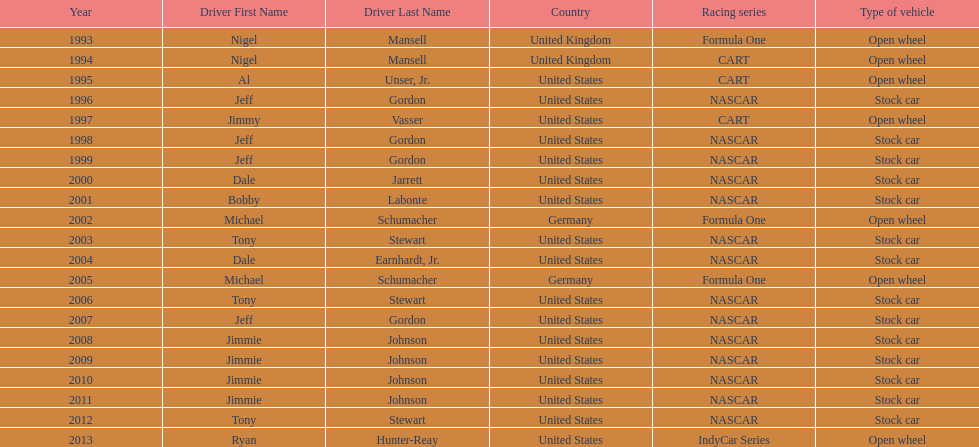Write the full table. {'header': ['Year', 'Driver First Name', 'Driver Last Name', 'Country', 'Racing series', 'Type of vehicle'], 'rows': [['1993', 'Nigel', 'Mansell', 'United Kingdom', 'Formula One', 'Open wheel'], ['1994', 'Nigel', 'Mansell', 'United Kingdom', 'CART', 'Open wheel'], ['1995', 'Al', 'Unser, Jr.', 'United States', 'CART', 'Open wheel'], ['1996', 'Jeff', 'Gordon', 'United States', 'NASCAR', 'Stock car'], ['1997', 'Jimmy', 'Vasser', 'United States', 'CART', 'Open wheel'], ['1998', 'Jeff', 'Gordon', 'United States', 'NASCAR', 'Stock car'], ['1999', 'Jeff', 'Gordon', 'United States', 'NASCAR', 'Stock car'], ['2000', 'Dale', 'Jarrett', 'United States', 'NASCAR', 'Stock car'], ['2001', 'Bobby', 'Labonte', 'United States', 'NASCAR', 'Stock car'], ['2002', 'Michael', 'Schumacher', 'Germany', 'Formula One', 'Open wheel'], ['2003', 'Tony', 'Stewart', 'United States', 'NASCAR', 'Stock car'], ['2004', 'Dale', 'Earnhardt, Jr.', 'United States', 'NASCAR', 'Stock car'], ['2005', 'Michael', 'Schumacher', 'Germany', 'Formula One', 'Open wheel'], ['2006', 'Tony', 'Stewart', 'United States', 'NASCAR', 'Stock car'], ['2007', 'Jeff', 'Gordon', 'United States', 'NASCAR', 'Stock car'], ['2008', 'Jimmie', 'Johnson', 'United States', 'NASCAR', 'Stock car'], ['2009', 'Jimmie', 'Johnson', 'United States', 'NASCAR', 'Stock car'], ['2010', 'Jimmie', 'Johnson', 'United States', 'NASCAR', 'Stock car'], ['2011', 'Jimmie', 'Johnson', 'United States', 'NASCAR', 'Stock car'], ['2012', 'Tony', 'Stewart', 'United States', 'NASCAR', 'Stock car'], ['2013', 'Ryan', 'Hunter-Reay', 'United States', 'IndyCar Series', 'Open wheel']]} Does the united states have more nation of citzenship then united kingdom? Yes. 